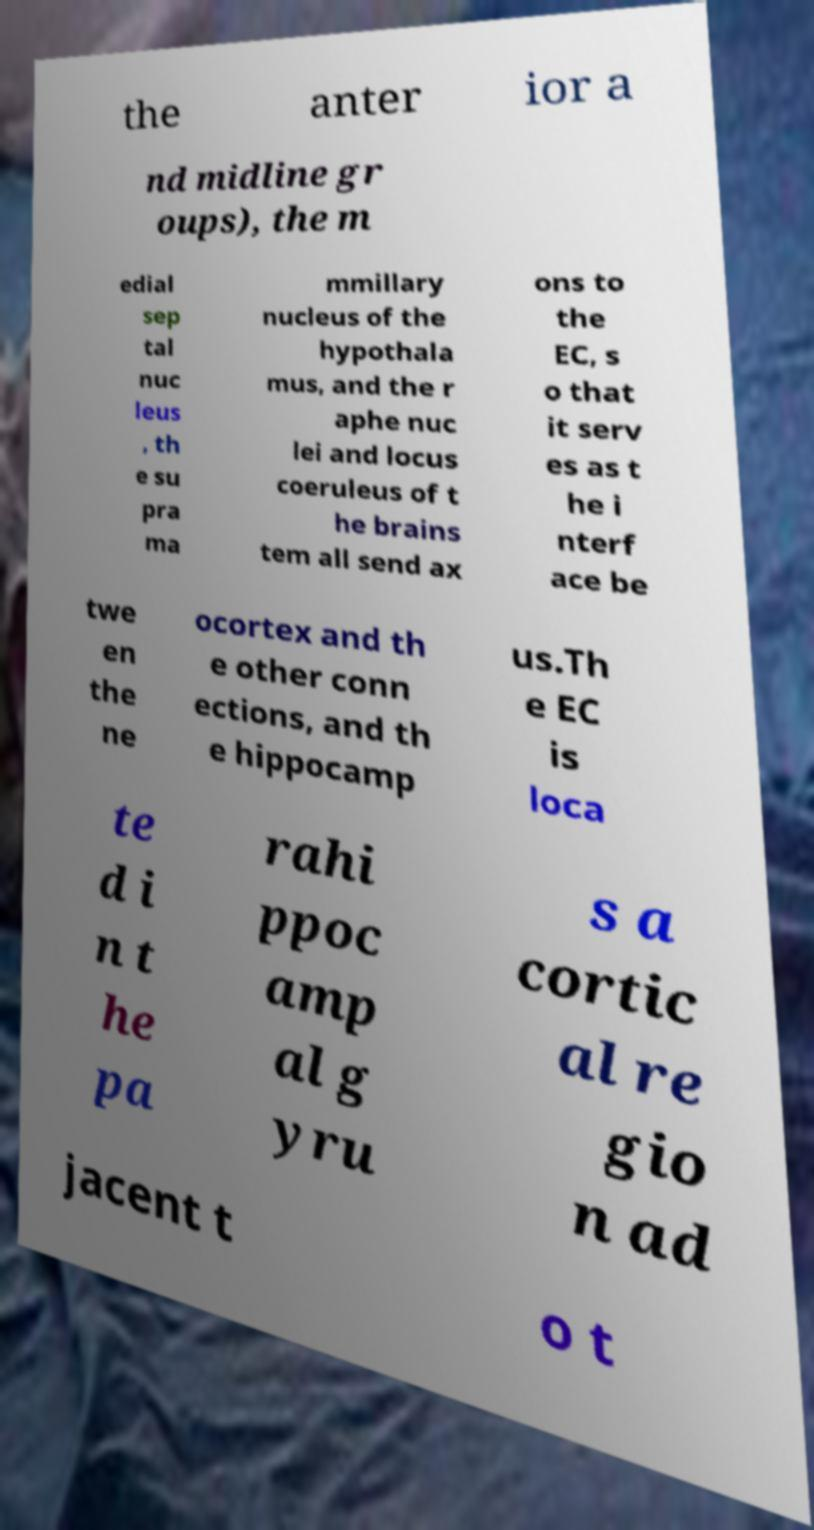For documentation purposes, I need the text within this image transcribed. Could you provide that? the anter ior a nd midline gr oups), the m edial sep tal nuc leus , th e su pra ma mmillary nucleus of the hypothala mus, and the r aphe nuc lei and locus coeruleus of t he brains tem all send ax ons to the EC, s o that it serv es as t he i nterf ace be twe en the ne ocortex and th e other conn ections, and th e hippocamp us.Th e EC is loca te d i n t he pa rahi ppoc amp al g yru s a cortic al re gio n ad jacent t o t 